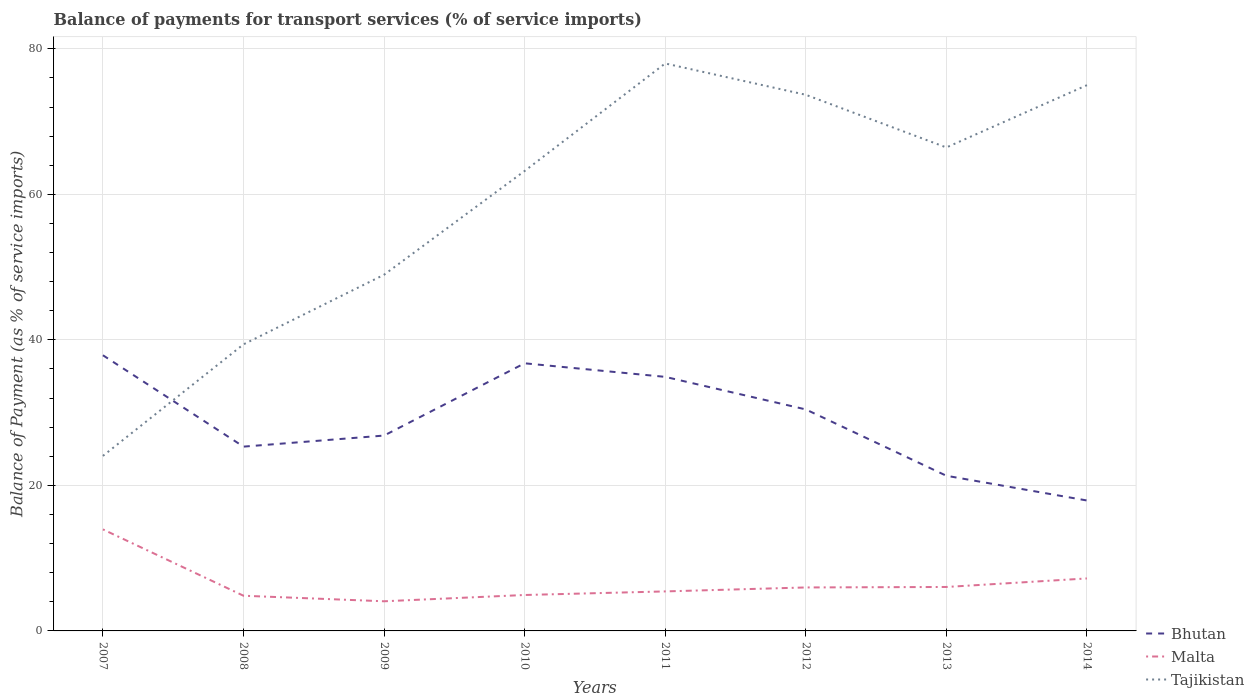Across all years, what is the maximum balance of payments for transport services in Bhutan?
Give a very brief answer. 17.93. What is the total balance of payments for transport services in Tajikistan in the graph?
Your response must be concise. -49.63. What is the difference between the highest and the second highest balance of payments for transport services in Tajikistan?
Provide a succinct answer. 53.93. What is the difference between the highest and the lowest balance of payments for transport services in Tajikistan?
Provide a succinct answer. 5. Is the balance of payments for transport services in Malta strictly greater than the balance of payments for transport services in Tajikistan over the years?
Your response must be concise. Yes. How many lines are there?
Give a very brief answer. 3. Are the values on the major ticks of Y-axis written in scientific E-notation?
Offer a very short reply. No. Does the graph contain grids?
Provide a succinct answer. Yes. How many legend labels are there?
Keep it short and to the point. 3. What is the title of the graph?
Offer a terse response. Balance of payments for transport services (% of service imports). What is the label or title of the Y-axis?
Make the answer very short. Balance of Payment (as % of service imports). What is the Balance of Payment (as % of service imports) of Bhutan in 2007?
Provide a succinct answer. 37.89. What is the Balance of Payment (as % of service imports) in Malta in 2007?
Provide a short and direct response. 13.96. What is the Balance of Payment (as % of service imports) in Tajikistan in 2007?
Ensure brevity in your answer.  24.05. What is the Balance of Payment (as % of service imports) of Bhutan in 2008?
Your response must be concise. 25.33. What is the Balance of Payment (as % of service imports) in Malta in 2008?
Ensure brevity in your answer.  4.84. What is the Balance of Payment (as % of service imports) of Tajikistan in 2008?
Ensure brevity in your answer.  39.38. What is the Balance of Payment (as % of service imports) of Bhutan in 2009?
Make the answer very short. 26.85. What is the Balance of Payment (as % of service imports) of Malta in 2009?
Keep it short and to the point. 4.07. What is the Balance of Payment (as % of service imports) of Tajikistan in 2009?
Provide a short and direct response. 48.95. What is the Balance of Payment (as % of service imports) of Bhutan in 2010?
Your answer should be very brief. 36.78. What is the Balance of Payment (as % of service imports) of Malta in 2010?
Give a very brief answer. 4.94. What is the Balance of Payment (as % of service imports) of Tajikistan in 2010?
Your answer should be compact. 63.21. What is the Balance of Payment (as % of service imports) in Bhutan in 2011?
Your answer should be compact. 34.91. What is the Balance of Payment (as % of service imports) of Malta in 2011?
Offer a terse response. 5.43. What is the Balance of Payment (as % of service imports) in Tajikistan in 2011?
Provide a short and direct response. 77.99. What is the Balance of Payment (as % of service imports) of Bhutan in 2012?
Provide a succinct answer. 30.44. What is the Balance of Payment (as % of service imports) in Malta in 2012?
Offer a very short reply. 5.97. What is the Balance of Payment (as % of service imports) in Tajikistan in 2012?
Keep it short and to the point. 73.68. What is the Balance of Payment (as % of service imports) of Bhutan in 2013?
Give a very brief answer. 21.32. What is the Balance of Payment (as % of service imports) of Malta in 2013?
Your response must be concise. 6.04. What is the Balance of Payment (as % of service imports) in Tajikistan in 2013?
Your answer should be very brief. 66.44. What is the Balance of Payment (as % of service imports) in Bhutan in 2014?
Offer a very short reply. 17.93. What is the Balance of Payment (as % of service imports) of Malta in 2014?
Keep it short and to the point. 7.21. What is the Balance of Payment (as % of service imports) of Tajikistan in 2014?
Offer a very short reply. 75. Across all years, what is the maximum Balance of Payment (as % of service imports) of Bhutan?
Ensure brevity in your answer.  37.89. Across all years, what is the maximum Balance of Payment (as % of service imports) in Malta?
Your response must be concise. 13.96. Across all years, what is the maximum Balance of Payment (as % of service imports) of Tajikistan?
Keep it short and to the point. 77.99. Across all years, what is the minimum Balance of Payment (as % of service imports) in Bhutan?
Offer a terse response. 17.93. Across all years, what is the minimum Balance of Payment (as % of service imports) in Malta?
Your answer should be compact. 4.07. Across all years, what is the minimum Balance of Payment (as % of service imports) in Tajikistan?
Provide a short and direct response. 24.05. What is the total Balance of Payment (as % of service imports) of Bhutan in the graph?
Ensure brevity in your answer.  231.45. What is the total Balance of Payment (as % of service imports) in Malta in the graph?
Ensure brevity in your answer.  52.46. What is the total Balance of Payment (as % of service imports) of Tajikistan in the graph?
Make the answer very short. 468.71. What is the difference between the Balance of Payment (as % of service imports) of Bhutan in 2007 and that in 2008?
Your answer should be compact. 12.56. What is the difference between the Balance of Payment (as % of service imports) of Malta in 2007 and that in 2008?
Your answer should be very brief. 9.12. What is the difference between the Balance of Payment (as % of service imports) of Tajikistan in 2007 and that in 2008?
Offer a terse response. -15.33. What is the difference between the Balance of Payment (as % of service imports) of Bhutan in 2007 and that in 2009?
Offer a very short reply. 11.04. What is the difference between the Balance of Payment (as % of service imports) of Malta in 2007 and that in 2009?
Your answer should be compact. 9.88. What is the difference between the Balance of Payment (as % of service imports) of Tajikistan in 2007 and that in 2009?
Offer a very short reply. -24.9. What is the difference between the Balance of Payment (as % of service imports) in Bhutan in 2007 and that in 2010?
Ensure brevity in your answer.  1.11. What is the difference between the Balance of Payment (as % of service imports) in Malta in 2007 and that in 2010?
Offer a very short reply. 9.02. What is the difference between the Balance of Payment (as % of service imports) of Tajikistan in 2007 and that in 2010?
Give a very brief answer. -39.16. What is the difference between the Balance of Payment (as % of service imports) in Bhutan in 2007 and that in 2011?
Your answer should be very brief. 2.97. What is the difference between the Balance of Payment (as % of service imports) in Malta in 2007 and that in 2011?
Keep it short and to the point. 8.53. What is the difference between the Balance of Payment (as % of service imports) of Tajikistan in 2007 and that in 2011?
Your answer should be compact. -53.93. What is the difference between the Balance of Payment (as % of service imports) of Bhutan in 2007 and that in 2012?
Offer a very short reply. 7.44. What is the difference between the Balance of Payment (as % of service imports) of Malta in 2007 and that in 2012?
Ensure brevity in your answer.  7.98. What is the difference between the Balance of Payment (as % of service imports) of Tajikistan in 2007 and that in 2012?
Provide a short and direct response. -49.63. What is the difference between the Balance of Payment (as % of service imports) in Bhutan in 2007 and that in 2013?
Your response must be concise. 16.56. What is the difference between the Balance of Payment (as % of service imports) in Malta in 2007 and that in 2013?
Your response must be concise. 7.92. What is the difference between the Balance of Payment (as % of service imports) of Tajikistan in 2007 and that in 2013?
Provide a succinct answer. -42.39. What is the difference between the Balance of Payment (as % of service imports) of Bhutan in 2007 and that in 2014?
Offer a terse response. 19.96. What is the difference between the Balance of Payment (as % of service imports) in Malta in 2007 and that in 2014?
Provide a succinct answer. 6.74. What is the difference between the Balance of Payment (as % of service imports) in Tajikistan in 2007 and that in 2014?
Make the answer very short. -50.95. What is the difference between the Balance of Payment (as % of service imports) in Bhutan in 2008 and that in 2009?
Give a very brief answer. -1.52. What is the difference between the Balance of Payment (as % of service imports) of Malta in 2008 and that in 2009?
Offer a terse response. 0.76. What is the difference between the Balance of Payment (as % of service imports) of Tajikistan in 2008 and that in 2009?
Ensure brevity in your answer.  -9.57. What is the difference between the Balance of Payment (as % of service imports) of Bhutan in 2008 and that in 2010?
Provide a short and direct response. -11.45. What is the difference between the Balance of Payment (as % of service imports) of Malta in 2008 and that in 2010?
Offer a very short reply. -0.1. What is the difference between the Balance of Payment (as % of service imports) of Tajikistan in 2008 and that in 2010?
Offer a terse response. -23.83. What is the difference between the Balance of Payment (as % of service imports) of Bhutan in 2008 and that in 2011?
Your answer should be very brief. -9.59. What is the difference between the Balance of Payment (as % of service imports) of Malta in 2008 and that in 2011?
Offer a very short reply. -0.59. What is the difference between the Balance of Payment (as % of service imports) in Tajikistan in 2008 and that in 2011?
Provide a succinct answer. -38.6. What is the difference between the Balance of Payment (as % of service imports) of Bhutan in 2008 and that in 2012?
Keep it short and to the point. -5.12. What is the difference between the Balance of Payment (as % of service imports) in Malta in 2008 and that in 2012?
Offer a terse response. -1.14. What is the difference between the Balance of Payment (as % of service imports) of Tajikistan in 2008 and that in 2012?
Provide a succinct answer. -34.3. What is the difference between the Balance of Payment (as % of service imports) of Bhutan in 2008 and that in 2013?
Offer a terse response. 4. What is the difference between the Balance of Payment (as % of service imports) in Malta in 2008 and that in 2013?
Provide a short and direct response. -1.2. What is the difference between the Balance of Payment (as % of service imports) of Tajikistan in 2008 and that in 2013?
Give a very brief answer. -27.06. What is the difference between the Balance of Payment (as % of service imports) in Bhutan in 2008 and that in 2014?
Make the answer very short. 7.4. What is the difference between the Balance of Payment (as % of service imports) of Malta in 2008 and that in 2014?
Offer a terse response. -2.38. What is the difference between the Balance of Payment (as % of service imports) in Tajikistan in 2008 and that in 2014?
Your response must be concise. -35.62. What is the difference between the Balance of Payment (as % of service imports) in Bhutan in 2009 and that in 2010?
Your response must be concise. -9.93. What is the difference between the Balance of Payment (as % of service imports) of Malta in 2009 and that in 2010?
Your response must be concise. -0.86. What is the difference between the Balance of Payment (as % of service imports) of Tajikistan in 2009 and that in 2010?
Provide a short and direct response. -14.26. What is the difference between the Balance of Payment (as % of service imports) of Bhutan in 2009 and that in 2011?
Make the answer very short. -8.07. What is the difference between the Balance of Payment (as % of service imports) of Malta in 2009 and that in 2011?
Your response must be concise. -1.36. What is the difference between the Balance of Payment (as % of service imports) in Tajikistan in 2009 and that in 2011?
Your answer should be very brief. -29.04. What is the difference between the Balance of Payment (as % of service imports) of Bhutan in 2009 and that in 2012?
Your answer should be very brief. -3.59. What is the difference between the Balance of Payment (as % of service imports) of Malta in 2009 and that in 2012?
Keep it short and to the point. -1.9. What is the difference between the Balance of Payment (as % of service imports) in Tajikistan in 2009 and that in 2012?
Keep it short and to the point. -24.73. What is the difference between the Balance of Payment (as % of service imports) of Bhutan in 2009 and that in 2013?
Your response must be concise. 5.52. What is the difference between the Balance of Payment (as % of service imports) of Malta in 2009 and that in 2013?
Ensure brevity in your answer.  -1.97. What is the difference between the Balance of Payment (as % of service imports) in Tajikistan in 2009 and that in 2013?
Offer a very short reply. -17.49. What is the difference between the Balance of Payment (as % of service imports) of Bhutan in 2009 and that in 2014?
Your answer should be very brief. 8.92. What is the difference between the Balance of Payment (as % of service imports) in Malta in 2009 and that in 2014?
Give a very brief answer. -3.14. What is the difference between the Balance of Payment (as % of service imports) of Tajikistan in 2009 and that in 2014?
Your response must be concise. -26.05. What is the difference between the Balance of Payment (as % of service imports) of Bhutan in 2010 and that in 2011?
Provide a succinct answer. 1.87. What is the difference between the Balance of Payment (as % of service imports) of Malta in 2010 and that in 2011?
Provide a short and direct response. -0.49. What is the difference between the Balance of Payment (as % of service imports) of Tajikistan in 2010 and that in 2011?
Offer a terse response. -14.78. What is the difference between the Balance of Payment (as % of service imports) of Bhutan in 2010 and that in 2012?
Keep it short and to the point. 6.34. What is the difference between the Balance of Payment (as % of service imports) in Malta in 2010 and that in 2012?
Your response must be concise. -1.04. What is the difference between the Balance of Payment (as % of service imports) of Tajikistan in 2010 and that in 2012?
Make the answer very short. -10.47. What is the difference between the Balance of Payment (as % of service imports) in Bhutan in 2010 and that in 2013?
Your response must be concise. 15.46. What is the difference between the Balance of Payment (as % of service imports) in Malta in 2010 and that in 2013?
Offer a very short reply. -1.1. What is the difference between the Balance of Payment (as % of service imports) in Tajikistan in 2010 and that in 2013?
Provide a succinct answer. -3.23. What is the difference between the Balance of Payment (as % of service imports) in Bhutan in 2010 and that in 2014?
Provide a succinct answer. 18.85. What is the difference between the Balance of Payment (as % of service imports) of Malta in 2010 and that in 2014?
Keep it short and to the point. -2.27. What is the difference between the Balance of Payment (as % of service imports) in Tajikistan in 2010 and that in 2014?
Offer a very short reply. -11.79. What is the difference between the Balance of Payment (as % of service imports) in Bhutan in 2011 and that in 2012?
Your answer should be compact. 4.47. What is the difference between the Balance of Payment (as % of service imports) of Malta in 2011 and that in 2012?
Give a very brief answer. -0.54. What is the difference between the Balance of Payment (as % of service imports) in Tajikistan in 2011 and that in 2012?
Provide a succinct answer. 4.3. What is the difference between the Balance of Payment (as % of service imports) in Bhutan in 2011 and that in 2013?
Ensure brevity in your answer.  13.59. What is the difference between the Balance of Payment (as % of service imports) in Malta in 2011 and that in 2013?
Keep it short and to the point. -0.61. What is the difference between the Balance of Payment (as % of service imports) in Tajikistan in 2011 and that in 2013?
Make the answer very short. 11.54. What is the difference between the Balance of Payment (as % of service imports) of Bhutan in 2011 and that in 2014?
Provide a short and direct response. 16.99. What is the difference between the Balance of Payment (as % of service imports) of Malta in 2011 and that in 2014?
Provide a short and direct response. -1.78. What is the difference between the Balance of Payment (as % of service imports) of Tajikistan in 2011 and that in 2014?
Make the answer very short. 2.98. What is the difference between the Balance of Payment (as % of service imports) of Bhutan in 2012 and that in 2013?
Your response must be concise. 9.12. What is the difference between the Balance of Payment (as % of service imports) of Malta in 2012 and that in 2013?
Provide a short and direct response. -0.07. What is the difference between the Balance of Payment (as % of service imports) of Tajikistan in 2012 and that in 2013?
Offer a very short reply. 7.24. What is the difference between the Balance of Payment (as % of service imports) in Bhutan in 2012 and that in 2014?
Offer a very short reply. 12.52. What is the difference between the Balance of Payment (as % of service imports) in Malta in 2012 and that in 2014?
Your response must be concise. -1.24. What is the difference between the Balance of Payment (as % of service imports) in Tajikistan in 2012 and that in 2014?
Your answer should be very brief. -1.32. What is the difference between the Balance of Payment (as % of service imports) of Bhutan in 2013 and that in 2014?
Offer a very short reply. 3.4. What is the difference between the Balance of Payment (as % of service imports) in Malta in 2013 and that in 2014?
Keep it short and to the point. -1.17. What is the difference between the Balance of Payment (as % of service imports) of Tajikistan in 2013 and that in 2014?
Make the answer very short. -8.56. What is the difference between the Balance of Payment (as % of service imports) in Bhutan in 2007 and the Balance of Payment (as % of service imports) in Malta in 2008?
Your response must be concise. 33.05. What is the difference between the Balance of Payment (as % of service imports) in Bhutan in 2007 and the Balance of Payment (as % of service imports) in Tajikistan in 2008?
Offer a terse response. -1.5. What is the difference between the Balance of Payment (as % of service imports) of Malta in 2007 and the Balance of Payment (as % of service imports) of Tajikistan in 2008?
Offer a terse response. -25.43. What is the difference between the Balance of Payment (as % of service imports) in Bhutan in 2007 and the Balance of Payment (as % of service imports) in Malta in 2009?
Your response must be concise. 33.81. What is the difference between the Balance of Payment (as % of service imports) of Bhutan in 2007 and the Balance of Payment (as % of service imports) of Tajikistan in 2009?
Ensure brevity in your answer.  -11.06. What is the difference between the Balance of Payment (as % of service imports) of Malta in 2007 and the Balance of Payment (as % of service imports) of Tajikistan in 2009?
Provide a succinct answer. -34.99. What is the difference between the Balance of Payment (as % of service imports) in Bhutan in 2007 and the Balance of Payment (as % of service imports) in Malta in 2010?
Provide a succinct answer. 32.95. What is the difference between the Balance of Payment (as % of service imports) of Bhutan in 2007 and the Balance of Payment (as % of service imports) of Tajikistan in 2010?
Your answer should be compact. -25.32. What is the difference between the Balance of Payment (as % of service imports) in Malta in 2007 and the Balance of Payment (as % of service imports) in Tajikistan in 2010?
Your answer should be very brief. -49.25. What is the difference between the Balance of Payment (as % of service imports) in Bhutan in 2007 and the Balance of Payment (as % of service imports) in Malta in 2011?
Provide a short and direct response. 32.46. What is the difference between the Balance of Payment (as % of service imports) of Bhutan in 2007 and the Balance of Payment (as % of service imports) of Tajikistan in 2011?
Keep it short and to the point. -40.1. What is the difference between the Balance of Payment (as % of service imports) of Malta in 2007 and the Balance of Payment (as % of service imports) of Tajikistan in 2011?
Ensure brevity in your answer.  -64.03. What is the difference between the Balance of Payment (as % of service imports) of Bhutan in 2007 and the Balance of Payment (as % of service imports) of Malta in 2012?
Your answer should be very brief. 31.91. What is the difference between the Balance of Payment (as % of service imports) of Bhutan in 2007 and the Balance of Payment (as % of service imports) of Tajikistan in 2012?
Keep it short and to the point. -35.8. What is the difference between the Balance of Payment (as % of service imports) of Malta in 2007 and the Balance of Payment (as % of service imports) of Tajikistan in 2012?
Provide a short and direct response. -59.73. What is the difference between the Balance of Payment (as % of service imports) in Bhutan in 2007 and the Balance of Payment (as % of service imports) in Malta in 2013?
Offer a terse response. 31.84. What is the difference between the Balance of Payment (as % of service imports) in Bhutan in 2007 and the Balance of Payment (as % of service imports) in Tajikistan in 2013?
Keep it short and to the point. -28.56. What is the difference between the Balance of Payment (as % of service imports) in Malta in 2007 and the Balance of Payment (as % of service imports) in Tajikistan in 2013?
Your response must be concise. -52.49. What is the difference between the Balance of Payment (as % of service imports) in Bhutan in 2007 and the Balance of Payment (as % of service imports) in Malta in 2014?
Your answer should be very brief. 30.67. What is the difference between the Balance of Payment (as % of service imports) of Bhutan in 2007 and the Balance of Payment (as % of service imports) of Tajikistan in 2014?
Provide a short and direct response. -37.12. What is the difference between the Balance of Payment (as % of service imports) in Malta in 2007 and the Balance of Payment (as % of service imports) in Tajikistan in 2014?
Your answer should be very brief. -61.05. What is the difference between the Balance of Payment (as % of service imports) in Bhutan in 2008 and the Balance of Payment (as % of service imports) in Malta in 2009?
Provide a short and direct response. 21.25. What is the difference between the Balance of Payment (as % of service imports) in Bhutan in 2008 and the Balance of Payment (as % of service imports) in Tajikistan in 2009?
Ensure brevity in your answer.  -23.62. What is the difference between the Balance of Payment (as % of service imports) in Malta in 2008 and the Balance of Payment (as % of service imports) in Tajikistan in 2009?
Offer a terse response. -44.11. What is the difference between the Balance of Payment (as % of service imports) in Bhutan in 2008 and the Balance of Payment (as % of service imports) in Malta in 2010?
Your answer should be very brief. 20.39. What is the difference between the Balance of Payment (as % of service imports) in Bhutan in 2008 and the Balance of Payment (as % of service imports) in Tajikistan in 2010?
Offer a terse response. -37.88. What is the difference between the Balance of Payment (as % of service imports) in Malta in 2008 and the Balance of Payment (as % of service imports) in Tajikistan in 2010?
Your answer should be compact. -58.37. What is the difference between the Balance of Payment (as % of service imports) of Bhutan in 2008 and the Balance of Payment (as % of service imports) of Malta in 2011?
Make the answer very short. 19.9. What is the difference between the Balance of Payment (as % of service imports) of Bhutan in 2008 and the Balance of Payment (as % of service imports) of Tajikistan in 2011?
Ensure brevity in your answer.  -52.66. What is the difference between the Balance of Payment (as % of service imports) of Malta in 2008 and the Balance of Payment (as % of service imports) of Tajikistan in 2011?
Give a very brief answer. -73.15. What is the difference between the Balance of Payment (as % of service imports) in Bhutan in 2008 and the Balance of Payment (as % of service imports) in Malta in 2012?
Ensure brevity in your answer.  19.35. What is the difference between the Balance of Payment (as % of service imports) in Bhutan in 2008 and the Balance of Payment (as % of service imports) in Tajikistan in 2012?
Your response must be concise. -48.35. What is the difference between the Balance of Payment (as % of service imports) of Malta in 2008 and the Balance of Payment (as % of service imports) of Tajikistan in 2012?
Provide a short and direct response. -68.85. What is the difference between the Balance of Payment (as % of service imports) in Bhutan in 2008 and the Balance of Payment (as % of service imports) in Malta in 2013?
Provide a short and direct response. 19.29. What is the difference between the Balance of Payment (as % of service imports) in Bhutan in 2008 and the Balance of Payment (as % of service imports) in Tajikistan in 2013?
Your answer should be compact. -41.12. What is the difference between the Balance of Payment (as % of service imports) of Malta in 2008 and the Balance of Payment (as % of service imports) of Tajikistan in 2013?
Make the answer very short. -61.61. What is the difference between the Balance of Payment (as % of service imports) of Bhutan in 2008 and the Balance of Payment (as % of service imports) of Malta in 2014?
Offer a very short reply. 18.11. What is the difference between the Balance of Payment (as % of service imports) in Bhutan in 2008 and the Balance of Payment (as % of service imports) in Tajikistan in 2014?
Your response must be concise. -49.67. What is the difference between the Balance of Payment (as % of service imports) of Malta in 2008 and the Balance of Payment (as % of service imports) of Tajikistan in 2014?
Your answer should be compact. -70.17. What is the difference between the Balance of Payment (as % of service imports) in Bhutan in 2009 and the Balance of Payment (as % of service imports) in Malta in 2010?
Ensure brevity in your answer.  21.91. What is the difference between the Balance of Payment (as % of service imports) of Bhutan in 2009 and the Balance of Payment (as % of service imports) of Tajikistan in 2010?
Provide a succinct answer. -36.36. What is the difference between the Balance of Payment (as % of service imports) of Malta in 2009 and the Balance of Payment (as % of service imports) of Tajikistan in 2010?
Give a very brief answer. -59.14. What is the difference between the Balance of Payment (as % of service imports) of Bhutan in 2009 and the Balance of Payment (as % of service imports) of Malta in 2011?
Ensure brevity in your answer.  21.42. What is the difference between the Balance of Payment (as % of service imports) in Bhutan in 2009 and the Balance of Payment (as % of service imports) in Tajikistan in 2011?
Offer a terse response. -51.14. What is the difference between the Balance of Payment (as % of service imports) in Malta in 2009 and the Balance of Payment (as % of service imports) in Tajikistan in 2011?
Your answer should be very brief. -73.91. What is the difference between the Balance of Payment (as % of service imports) of Bhutan in 2009 and the Balance of Payment (as % of service imports) of Malta in 2012?
Make the answer very short. 20.87. What is the difference between the Balance of Payment (as % of service imports) of Bhutan in 2009 and the Balance of Payment (as % of service imports) of Tajikistan in 2012?
Your answer should be compact. -46.83. What is the difference between the Balance of Payment (as % of service imports) of Malta in 2009 and the Balance of Payment (as % of service imports) of Tajikistan in 2012?
Your answer should be very brief. -69.61. What is the difference between the Balance of Payment (as % of service imports) in Bhutan in 2009 and the Balance of Payment (as % of service imports) in Malta in 2013?
Provide a succinct answer. 20.81. What is the difference between the Balance of Payment (as % of service imports) of Bhutan in 2009 and the Balance of Payment (as % of service imports) of Tajikistan in 2013?
Your answer should be compact. -39.59. What is the difference between the Balance of Payment (as % of service imports) in Malta in 2009 and the Balance of Payment (as % of service imports) in Tajikistan in 2013?
Your answer should be very brief. -62.37. What is the difference between the Balance of Payment (as % of service imports) of Bhutan in 2009 and the Balance of Payment (as % of service imports) of Malta in 2014?
Your answer should be very brief. 19.64. What is the difference between the Balance of Payment (as % of service imports) of Bhutan in 2009 and the Balance of Payment (as % of service imports) of Tajikistan in 2014?
Keep it short and to the point. -48.15. What is the difference between the Balance of Payment (as % of service imports) of Malta in 2009 and the Balance of Payment (as % of service imports) of Tajikistan in 2014?
Your response must be concise. -70.93. What is the difference between the Balance of Payment (as % of service imports) in Bhutan in 2010 and the Balance of Payment (as % of service imports) in Malta in 2011?
Ensure brevity in your answer.  31.35. What is the difference between the Balance of Payment (as % of service imports) in Bhutan in 2010 and the Balance of Payment (as % of service imports) in Tajikistan in 2011?
Make the answer very short. -41.21. What is the difference between the Balance of Payment (as % of service imports) of Malta in 2010 and the Balance of Payment (as % of service imports) of Tajikistan in 2011?
Offer a terse response. -73.05. What is the difference between the Balance of Payment (as % of service imports) in Bhutan in 2010 and the Balance of Payment (as % of service imports) in Malta in 2012?
Your response must be concise. 30.81. What is the difference between the Balance of Payment (as % of service imports) in Bhutan in 2010 and the Balance of Payment (as % of service imports) in Tajikistan in 2012?
Your answer should be compact. -36.9. What is the difference between the Balance of Payment (as % of service imports) of Malta in 2010 and the Balance of Payment (as % of service imports) of Tajikistan in 2012?
Keep it short and to the point. -68.74. What is the difference between the Balance of Payment (as % of service imports) of Bhutan in 2010 and the Balance of Payment (as % of service imports) of Malta in 2013?
Your answer should be compact. 30.74. What is the difference between the Balance of Payment (as % of service imports) in Bhutan in 2010 and the Balance of Payment (as % of service imports) in Tajikistan in 2013?
Give a very brief answer. -29.66. What is the difference between the Balance of Payment (as % of service imports) in Malta in 2010 and the Balance of Payment (as % of service imports) in Tajikistan in 2013?
Keep it short and to the point. -61.5. What is the difference between the Balance of Payment (as % of service imports) of Bhutan in 2010 and the Balance of Payment (as % of service imports) of Malta in 2014?
Your answer should be compact. 29.57. What is the difference between the Balance of Payment (as % of service imports) of Bhutan in 2010 and the Balance of Payment (as % of service imports) of Tajikistan in 2014?
Your answer should be compact. -38.22. What is the difference between the Balance of Payment (as % of service imports) of Malta in 2010 and the Balance of Payment (as % of service imports) of Tajikistan in 2014?
Give a very brief answer. -70.06. What is the difference between the Balance of Payment (as % of service imports) in Bhutan in 2011 and the Balance of Payment (as % of service imports) in Malta in 2012?
Offer a terse response. 28.94. What is the difference between the Balance of Payment (as % of service imports) of Bhutan in 2011 and the Balance of Payment (as % of service imports) of Tajikistan in 2012?
Provide a succinct answer. -38.77. What is the difference between the Balance of Payment (as % of service imports) of Malta in 2011 and the Balance of Payment (as % of service imports) of Tajikistan in 2012?
Your answer should be compact. -68.25. What is the difference between the Balance of Payment (as % of service imports) of Bhutan in 2011 and the Balance of Payment (as % of service imports) of Malta in 2013?
Your response must be concise. 28.87. What is the difference between the Balance of Payment (as % of service imports) in Bhutan in 2011 and the Balance of Payment (as % of service imports) in Tajikistan in 2013?
Offer a terse response. -31.53. What is the difference between the Balance of Payment (as % of service imports) in Malta in 2011 and the Balance of Payment (as % of service imports) in Tajikistan in 2013?
Keep it short and to the point. -61.01. What is the difference between the Balance of Payment (as % of service imports) of Bhutan in 2011 and the Balance of Payment (as % of service imports) of Malta in 2014?
Your answer should be very brief. 27.7. What is the difference between the Balance of Payment (as % of service imports) of Bhutan in 2011 and the Balance of Payment (as % of service imports) of Tajikistan in 2014?
Keep it short and to the point. -40.09. What is the difference between the Balance of Payment (as % of service imports) in Malta in 2011 and the Balance of Payment (as % of service imports) in Tajikistan in 2014?
Your response must be concise. -69.57. What is the difference between the Balance of Payment (as % of service imports) of Bhutan in 2012 and the Balance of Payment (as % of service imports) of Malta in 2013?
Give a very brief answer. 24.4. What is the difference between the Balance of Payment (as % of service imports) of Bhutan in 2012 and the Balance of Payment (as % of service imports) of Tajikistan in 2013?
Offer a very short reply. -36. What is the difference between the Balance of Payment (as % of service imports) of Malta in 2012 and the Balance of Payment (as % of service imports) of Tajikistan in 2013?
Your answer should be very brief. -60.47. What is the difference between the Balance of Payment (as % of service imports) in Bhutan in 2012 and the Balance of Payment (as % of service imports) in Malta in 2014?
Ensure brevity in your answer.  23.23. What is the difference between the Balance of Payment (as % of service imports) of Bhutan in 2012 and the Balance of Payment (as % of service imports) of Tajikistan in 2014?
Offer a very short reply. -44.56. What is the difference between the Balance of Payment (as % of service imports) of Malta in 2012 and the Balance of Payment (as % of service imports) of Tajikistan in 2014?
Your response must be concise. -69.03. What is the difference between the Balance of Payment (as % of service imports) of Bhutan in 2013 and the Balance of Payment (as % of service imports) of Malta in 2014?
Provide a short and direct response. 14.11. What is the difference between the Balance of Payment (as % of service imports) in Bhutan in 2013 and the Balance of Payment (as % of service imports) in Tajikistan in 2014?
Give a very brief answer. -53.68. What is the difference between the Balance of Payment (as % of service imports) in Malta in 2013 and the Balance of Payment (as % of service imports) in Tajikistan in 2014?
Give a very brief answer. -68.96. What is the average Balance of Payment (as % of service imports) in Bhutan per year?
Make the answer very short. 28.93. What is the average Balance of Payment (as % of service imports) in Malta per year?
Keep it short and to the point. 6.56. What is the average Balance of Payment (as % of service imports) in Tajikistan per year?
Make the answer very short. 58.59. In the year 2007, what is the difference between the Balance of Payment (as % of service imports) in Bhutan and Balance of Payment (as % of service imports) in Malta?
Give a very brief answer. 23.93. In the year 2007, what is the difference between the Balance of Payment (as % of service imports) in Bhutan and Balance of Payment (as % of service imports) in Tajikistan?
Provide a succinct answer. 13.83. In the year 2007, what is the difference between the Balance of Payment (as % of service imports) of Malta and Balance of Payment (as % of service imports) of Tajikistan?
Give a very brief answer. -10.1. In the year 2008, what is the difference between the Balance of Payment (as % of service imports) of Bhutan and Balance of Payment (as % of service imports) of Malta?
Provide a short and direct response. 20.49. In the year 2008, what is the difference between the Balance of Payment (as % of service imports) in Bhutan and Balance of Payment (as % of service imports) in Tajikistan?
Ensure brevity in your answer.  -14.06. In the year 2008, what is the difference between the Balance of Payment (as % of service imports) of Malta and Balance of Payment (as % of service imports) of Tajikistan?
Provide a succinct answer. -34.55. In the year 2009, what is the difference between the Balance of Payment (as % of service imports) of Bhutan and Balance of Payment (as % of service imports) of Malta?
Give a very brief answer. 22.77. In the year 2009, what is the difference between the Balance of Payment (as % of service imports) in Bhutan and Balance of Payment (as % of service imports) in Tajikistan?
Keep it short and to the point. -22.1. In the year 2009, what is the difference between the Balance of Payment (as % of service imports) in Malta and Balance of Payment (as % of service imports) in Tajikistan?
Provide a succinct answer. -44.88. In the year 2010, what is the difference between the Balance of Payment (as % of service imports) of Bhutan and Balance of Payment (as % of service imports) of Malta?
Offer a very short reply. 31.84. In the year 2010, what is the difference between the Balance of Payment (as % of service imports) of Bhutan and Balance of Payment (as % of service imports) of Tajikistan?
Ensure brevity in your answer.  -26.43. In the year 2010, what is the difference between the Balance of Payment (as % of service imports) in Malta and Balance of Payment (as % of service imports) in Tajikistan?
Offer a very short reply. -58.27. In the year 2011, what is the difference between the Balance of Payment (as % of service imports) in Bhutan and Balance of Payment (as % of service imports) in Malta?
Make the answer very short. 29.48. In the year 2011, what is the difference between the Balance of Payment (as % of service imports) in Bhutan and Balance of Payment (as % of service imports) in Tajikistan?
Provide a short and direct response. -43.07. In the year 2011, what is the difference between the Balance of Payment (as % of service imports) in Malta and Balance of Payment (as % of service imports) in Tajikistan?
Your answer should be very brief. -72.56. In the year 2012, what is the difference between the Balance of Payment (as % of service imports) in Bhutan and Balance of Payment (as % of service imports) in Malta?
Keep it short and to the point. 24.47. In the year 2012, what is the difference between the Balance of Payment (as % of service imports) in Bhutan and Balance of Payment (as % of service imports) in Tajikistan?
Ensure brevity in your answer.  -43.24. In the year 2012, what is the difference between the Balance of Payment (as % of service imports) in Malta and Balance of Payment (as % of service imports) in Tajikistan?
Provide a succinct answer. -67.71. In the year 2013, what is the difference between the Balance of Payment (as % of service imports) in Bhutan and Balance of Payment (as % of service imports) in Malta?
Your answer should be compact. 15.28. In the year 2013, what is the difference between the Balance of Payment (as % of service imports) of Bhutan and Balance of Payment (as % of service imports) of Tajikistan?
Offer a terse response. -45.12. In the year 2013, what is the difference between the Balance of Payment (as % of service imports) in Malta and Balance of Payment (as % of service imports) in Tajikistan?
Offer a terse response. -60.4. In the year 2014, what is the difference between the Balance of Payment (as % of service imports) in Bhutan and Balance of Payment (as % of service imports) in Malta?
Keep it short and to the point. 10.71. In the year 2014, what is the difference between the Balance of Payment (as % of service imports) in Bhutan and Balance of Payment (as % of service imports) in Tajikistan?
Ensure brevity in your answer.  -57.08. In the year 2014, what is the difference between the Balance of Payment (as % of service imports) in Malta and Balance of Payment (as % of service imports) in Tajikistan?
Your answer should be very brief. -67.79. What is the ratio of the Balance of Payment (as % of service imports) in Bhutan in 2007 to that in 2008?
Give a very brief answer. 1.5. What is the ratio of the Balance of Payment (as % of service imports) of Malta in 2007 to that in 2008?
Provide a short and direct response. 2.89. What is the ratio of the Balance of Payment (as % of service imports) of Tajikistan in 2007 to that in 2008?
Your response must be concise. 0.61. What is the ratio of the Balance of Payment (as % of service imports) of Bhutan in 2007 to that in 2009?
Offer a terse response. 1.41. What is the ratio of the Balance of Payment (as % of service imports) of Malta in 2007 to that in 2009?
Keep it short and to the point. 3.43. What is the ratio of the Balance of Payment (as % of service imports) of Tajikistan in 2007 to that in 2009?
Keep it short and to the point. 0.49. What is the ratio of the Balance of Payment (as % of service imports) of Malta in 2007 to that in 2010?
Offer a very short reply. 2.83. What is the ratio of the Balance of Payment (as % of service imports) of Tajikistan in 2007 to that in 2010?
Your answer should be compact. 0.38. What is the ratio of the Balance of Payment (as % of service imports) of Bhutan in 2007 to that in 2011?
Provide a succinct answer. 1.09. What is the ratio of the Balance of Payment (as % of service imports) in Malta in 2007 to that in 2011?
Offer a terse response. 2.57. What is the ratio of the Balance of Payment (as % of service imports) in Tajikistan in 2007 to that in 2011?
Keep it short and to the point. 0.31. What is the ratio of the Balance of Payment (as % of service imports) of Bhutan in 2007 to that in 2012?
Provide a succinct answer. 1.24. What is the ratio of the Balance of Payment (as % of service imports) in Malta in 2007 to that in 2012?
Make the answer very short. 2.34. What is the ratio of the Balance of Payment (as % of service imports) in Tajikistan in 2007 to that in 2012?
Your response must be concise. 0.33. What is the ratio of the Balance of Payment (as % of service imports) of Bhutan in 2007 to that in 2013?
Your answer should be very brief. 1.78. What is the ratio of the Balance of Payment (as % of service imports) of Malta in 2007 to that in 2013?
Provide a short and direct response. 2.31. What is the ratio of the Balance of Payment (as % of service imports) in Tajikistan in 2007 to that in 2013?
Give a very brief answer. 0.36. What is the ratio of the Balance of Payment (as % of service imports) of Bhutan in 2007 to that in 2014?
Offer a terse response. 2.11. What is the ratio of the Balance of Payment (as % of service imports) of Malta in 2007 to that in 2014?
Keep it short and to the point. 1.93. What is the ratio of the Balance of Payment (as % of service imports) of Tajikistan in 2007 to that in 2014?
Your response must be concise. 0.32. What is the ratio of the Balance of Payment (as % of service imports) in Bhutan in 2008 to that in 2009?
Your answer should be very brief. 0.94. What is the ratio of the Balance of Payment (as % of service imports) in Malta in 2008 to that in 2009?
Your response must be concise. 1.19. What is the ratio of the Balance of Payment (as % of service imports) of Tajikistan in 2008 to that in 2009?
Offer a very short reply. 0.8. What is the ratio of the Balance of Payment (as % of service imports) of Bhutan in 2008 to that in 2010?
Provide a short and direct response. 0.69. What is the ratio of the Balance of Payment (as % of service imports) in Malta in 2008 to that in 2010?
Keep it short and to the point. 0.98. What is the ratio of the Balance of Payment (as % of service imports) of Tajikistan in 2008 to that in 2010?
Keep it short and to the point. 0.62. What is the ratio of the Balance of Payment (as % of service imports) in Bhutan in 2008 to that in 2011?
Provide a succinct answer. 0.73. What is the ratio of the Balance of Payment (as % of service imports) in Malta in 2008 to that in 2011?
Make the answer very short. 0.89. What is the ratio of the Balance of Payment (as % of service imports) of Tajikistan in 2008 to that in 2011?
Your answer should be very brief. 0.51. What is the ratio of the Balance of Payment (as % of service imports) of Bhutan in 2008 to that in 2012?
Keep it short and to the point. 0.83. What is the ratio of the Balance of Payment (as % of service imports) of Malta in 2008 to that in 2012?
Offer a very short reply. 0.81. What is the ratio of the Balance of Payment (as % of service imports) in Tajikistan in 2008 to that in 2012?
Offer a very short reply. 0.53. What is the ratio of the Balance of Payment (as % of service imports) of Bhutan in 2008 to that in 2013?
Provide a succinct answer. 1.19. What is the ratio of the Balance of Payment (as % of service imports) in Malta in 2008 to that in 2013?
Your answer should be very brief. 0.8. What is the ratio of the Balance of Payment (as % of service imports) of Tajikistan in 2008 to that in 2013?
Your answer should be compact. 0.59. What is the ratio of the Balance of Payment (as % of service imports) of Bhutan in 2008 to that in 2014?
Offer a very short reply. 1.41. What is the ratio of the Balance of Payment (as % of service imports) in Malta in 2008 to that in 2014?
Make the answer very short. 0.67. What is the ratio of the Balance of Payment (as % of service imports) of Tajikistan in 2008 to that in 2014?
Provide a succinct answer. 0.53. What is the ratio of the Balance of Payment (as % of service imports) in Bhutan in 2009 to that in 2010?
Offer a very short reply. 0.73. What is the ratio of the Balance of Payment (as % of service imports) in Malta in 2009 to that in 2010?
Ensure brevity in your answer.  0.82. What is the ratio of the Balance of Payment (as % of service imports) of Tajikistan in 2009 to that in 2010?
Offer a very short reply. 0.77. What is the ratio of the Balance of Payment (as % of service imports) in Bhutan in 2009 to that in 2011?
Your answer should be compact. 0.77. What is the ratio of the Balance of Payment (as % of service imports) in Malta in 2009 to that in 2011?
Provide a succinct answer. 0.75. What is the ratio of the Balance of Payment (as % of service imports) of Tajikistan in 2009 to that in 2011?
Ensure brevity in your answer.  0.63. What is the ratio of the Balance of Payment (as % of service imports) of Bhutan in 2009 to that in 2012?
Give a very brief answer. 0.88. What is the ratio of the Balance of Payment (as % of service imports) of Malta in 2009 to that in 2012?
Provide a succinct answer. 0.68. What is the ratio of the Balance of Payment (as % of service imports) of Tajikistan in 2009 to that in 2012?
Make the answer very short. 0.66. What is the ratio of the Balance of Payment (as % of service imports) of Bhutan in 2009 to that in 2013?
Ensure brevity in your answer.  1.26. What is the ratio of the Balance of Payment (as % of service imports) of Malta in 2009 to that in 2013?
Offer a terse response. 0.67. What is the ratio of the Balance of Payment (as % of service imports) in Tajikistan in 2009 to that in 2013?
Your response must be concise. 0.74. What is the ratio of the Balance of Payment (as % of service imports) in Bhutan in 2009 to that in 2014?
Provide a succinct answer. 1.5. What is the ratio of the Balance of Payment (as % of service imports) in Malta in 2009 to that in 2014?
Your answer should be very brief. 0.56. What is the ratio of the Balance of Payment (as % of service imports) of Tajikistan in 2009 to that in 2014?
Your answer should be compact. 0.65. What is the ratio of the Balance of Payment (as % of service imports) of Bhutan in 2010 to that in 2011?
Your answer should be compact. 1.05. What is the ratio of the Balance of Payment (as % of service imports) in Malta in 2010 to that in 2011?
Offer a very short reply. 0.91. What is the ratio of the Balance of Payment (as % of service imports) in Tajikistan in 2010 to that in 2011?
Your answer should be compact. 0.81. What is the ratio of the Balance of Payment (as % of service imports) in Bhutan in 2010 to that in 2012?
Your answer should be compact. 1.21. What is the ratio of the Balance of Payment (as % of service imports) in Malta in 2010 to that in 2012?
Give a very brief answer. 0.83. What is the ratio of the Balance of Payment (as % of service imports) in Tajikistan in 2010 to that in 2012?
Make the answer very short. 0.86. What is the ratio of the Balance of Payment (as % of service imports) of Bhutan in 2010 to that in 2013?
Your answer should be compact. 1.72. What is the ratio of the Balance of Payment (as % of service imports) in Malta in 2010 to that in 2013?
Give a very brief answer. 0.82. What is the ratio of the Balance of Payment (as % of service imports) in Tajikistan in 2010 to that in 2013?
Your answer should be compact. 0.95. What is the ratio of the Balance of Payment (as % of service imports) of Bhutan in 2010 to that in 2014?
Your response must be concise. 2.05. What is the ratio of the Balance of Payment (as % of service imports) in Malta in 2010 to that in 2014?
Your response must be concise. 0.68. What is the ratio of the Balance of Payment (as % of service imports) of Tajikistan in 2010 to that in 2014?
Your answer should be compact. 0.84. What is the ratio of the Balance of Payment (as % of service imports) in Bhutan in 2011 to that in 2012?
Ensure brevity in your answer.  1.15. What is the ratio of the Balance of Payment (as % of service imports) in Malta in 2011 to that in 2012?
Ensure brevity in your answer.  0.91. What is the ratio of the Balance of Payment (as % of service imports) in Tajikistan in 2011 to that in 2012?
Keep it short and to the point. 1.06. What is the ratio of the Balance of Payment (as % of service imports) in Bhutan in 2011 to that in 2013?
Offer a very short reply. 1.64. What is the ratio of the Balance of Payment (as % of service imports) in Malta in 2011 to that in 2013?
Give a very brief answer. 0.9. What is the ratio of the Balance of Payment (as % of service imports) in Tajikistan in 2011 to that in 2013?
Offer a very short reply. 1.17. What is the ratio of the Balance of Payment (as % of service imports) in Bhutan in 2011 to that in 2014?
Give a very brief answer. 1.95. What is the ratio of the Balance of Payment (as % of service imports) of Malta in 2011 to that in 2014?
Provide a short and direct response. 0.75. What is the ratio of the Balance of Payment (as % of service imports) in Tajikistan in 2011 to that in 2014?
Offer a very short reply. 1.04. What is the ratio of the Balance of Payment (as % of service imports) in Bhutan in 2012 to that in 2013?
Make the answer very short. 1.43. What is the ratio of the Balance of Payment (as % of service imports) of Malta in 2012 to that in 2013?
Offer a very short reply. 0.99. What is the ratio of the Balance of Payment (as % of service imports) of Tajikistan in 2012 to that in 2013?
Your response must be concise. 1.11. What is the ratio of the Balance of Payment (as % of service imports) of Bhutan in 2012 to that in 2014?
Your response must be concise. 1.7. What is the ratio of the Balance of Payment (as % of service imports) of Malta in 2012 to that in 2014?
Offer a terse response. 0.83. What is the ratio of the Balance of Payment (as % of service imports) of Tajikistan in 2012 to that in 2014?
Make the answer very short. 0.98. What is the ratio of the Balance of Payment (as % of service imports) in Bhutan in 2013 to that in 2014?
Keep it short and to the point. 1.19. What is the ratio of the Balance of Payment (as % of service imports) of Malta in 2013 to that in 2014?
Offer a terse response. 0.84. What is the ratio of the Balance of Payment (as % of service imports) of Tajikistan in 2013 to that in 2014?
Your answer should be very brief. 0.89. What is the difference between the highest and the second highest Balance of Payment (as % of service imports) in Bhutan?
Give a very brief answer. 1.11. What is the difference between the highest and the second highest Balance of Payment (as % of service imports) of Malta?
Offer a terse response. 6.74. What is the difference between the highest and the second highest Balance of Payment (as % of service imports) of Tajikistan?
Give a very brief answer. 2.98. What is the difference between the highest and the lowest Balance of Payment (as % of service imports) of Bhutan?
Your answer should be compact. 19.96. What is the difference between the highest and the lowest Balance of Payment (as % of service imports) in Malta?
Offer a very short reply. 9.88. What is the difference between the highest and the lowest Balance of Payment (as % of service imports) in Tajikistan?
Provide a succinct answer. 53.93. 